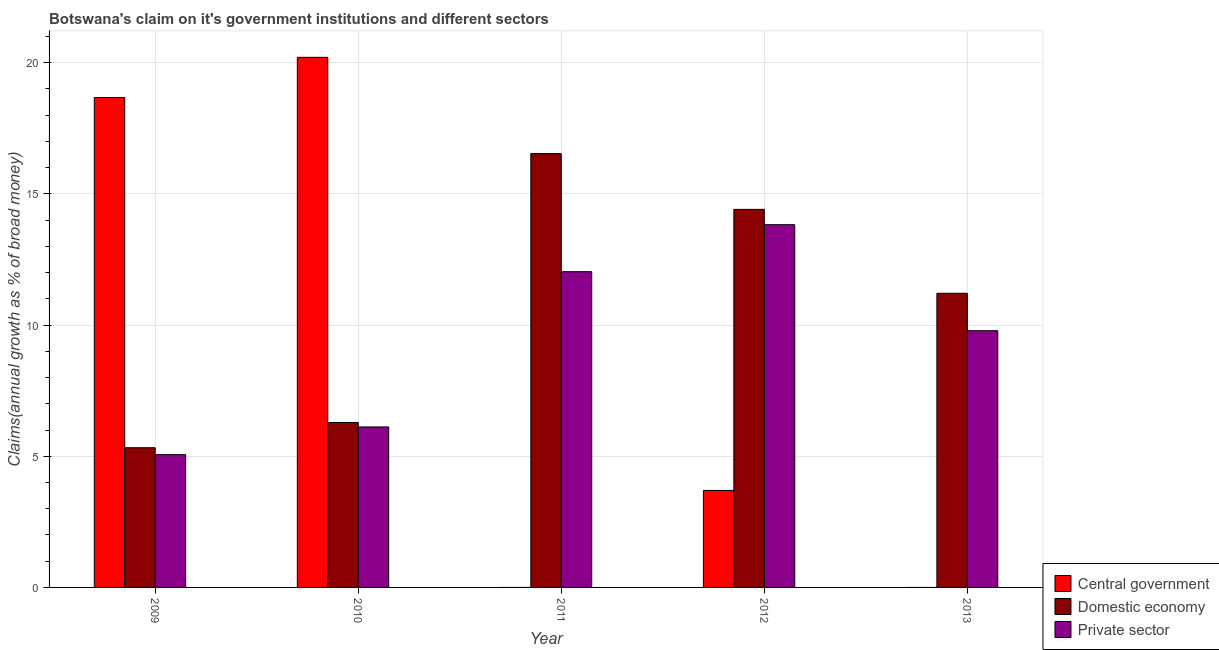How many different coloured bars are there?
Your answer should be very brief. 3. How many groups of bars are there?
Offer a terse response. 5. Are the number of bars per tick equal to the number of legend labels?
Provide a short and direct response. No. How many bars are there on the 4th tick from the left?
Your response must be concise. 3. How many bars are there on the 4th tick from the right?
Provide a succinct answer. 3. What is the label of the 5th group of bars from the left?
Ensure brevity in your answer.  2013. Across all years, what is the maximum percentage of claim on the private sector?
Give a very brief answer. 13.83. What is the total percentage of claim on the central government in the graph?
Your response must be concise. 42.58. What is the difference between the percentage of claim on the private sector in 2009 and that in 2012?
Keep it short and to the point. -8.77. What is the difference between the percentage of claim on the private sector in 2013 and the percentage of claim on the domestic economy in 2012?
Your response must be concise. -4.04. What is the average percentage of claim on the private sector per year?
Your answer should be very brief. 9.37. What is the ratio of the percentage of claim on the domestic economy in 2011 to that in 2012?
Your answer should be very brief. 1.15. Is the percentage of claim on the domestic economy in 2011 less than that in 2013?
Offer a very short reply. No. What is the difference between the highest and the second highest percentage of claim on the domestic economy?
Ensure brevity in your answer.  2.12. What is the difference between the highest and the lowest percentage of claim on the central government?
Make the answer very short. 20.21. Is the sum of the percentage of claim on the domestic economy in 2009 and 2010 greater than the maximum percentage of claim on the private sector across all years?
Make the answer very short. No. Is it the case that in every year, the sum of the percentage of claim on the central government and percentage of claim on the domestic economy is greater than the percentage of claim on the private sector?
Offer a very short reply. Yes. How many years are there in the graph?
Make the answer very short. 5. Does the graph contain any zero values?
Your answer should be very brief. Yes. Does the graph contain grids?
Offer a very short reply. Yes. How many legend labels are there?
Your answer should be very brief. 3. How are the legend labels stacked?
Ensure brevity in your answer.  Vertical. What is the title of the graph?
Provide a short and direct response. Botswana's claim on it's government institutions and different sectors. What is the label or title of the X-axis?
Provide a short and direct response. Year. What is the label or title of the Y-axis?
Offer a terse response. Claims(annual growth as % of broad money). What is the Claims(annual growth as % of broad money) in Central government in 2009?
Your response must be concise. 18.68. What is the Claims(annual growth as % of broad money) of Domestic economy in 2009?
Make the answer very short. 5.33. What is the Claims(annual growth as % of broad money) in Private sector in 2009?
Make the answer very short. 5.06. What is the Claims(annual growth as % of broad money) of Central government in 2010?
Your answer should be very brief. 20.21. What is the Claims(annual growth as % of broad money) in Domestic economy in 2010?
Your response must be concise. 6.29. What is the Claims(annual growth as % of broad money) of Private sector in 2010?
Your answer should be very brief. 6.12. What is the Claims(annual growth as % of broad money) of Central government in 2011?
Your answer should be compact. 0. What is the Claims(annual growth as % of broad money) in Domestic economy in 2011?
Keep it short and to the point. 16.54. What is the Claims(annual growth as % of broad money) in Private sector in 2011?
Your answer should be very brief. 12.04. What is the Claims(annual growth as % of broad money) of Central government in 2012?
Your answer should be compact. 3.7. What is the Claims(annual growth as % of broad money) of Domestic economy in 2012?
Offer a very short reply. 14.41. What is the Claims(annual growth as % of broad money) of Private sector in 2012?
Provide a short and direct response. 13.83. What is the Claims(annual growth as % of broad money) in Central government in 2013?
Give a very brief answer. 0. What is the Claims(annual growth as % of broad money) in Domestic economy in 2013?
Your answer should be very brief. 11.21. What is the Claims(annual growth as % of broad money) in Private sector in 2013?
Offer a very short reply. 9.79. Across all years, what is the maximum Claims(annual growth as % of broad money) of Central government?
Make the answer very short. 20.21. Across all years, what is the maximum Claims(annual growth as % of broad money) in Domestic economy?
Keep it short and to the point. 16.54. Across all years, what is the maximum Claims(annual growth as % of broad money) of Private sector?
Offer a terse response. 13.83. Across all years, what is the minimum Claims(annual growth as % of broad money) in Central government?
Your response must be concise. 0. Across all years, what is the minimum Claims(annual growth as % of broad money) of Domestic economy?
Provide a short and direct response. 5.33. Across all years, what is the minimum Claims(annual growth as % of broad money) in Private sector?
Provide a succinct answer. 5.06. What is the total Claims(annual growth as % of broad money) in Central government in the graph?
Provide a short and direct response. 42.58. What is the total Claims(annual growth as % of broad money) of Domestic economy in the graph?
Offer a terse response. 53.77. What is the total Claims(annual growth as % of broad money) of Private sector in the graph?
Your response must be concise. 46.83. What is the difference between the Claims(annual growth as % of broad money) of Central government in 2009 and that in 2010?
Keep it short and to the point. -1.53. What is the difference between the Claims(annual growth as % of broad money) of Domestic economy in 2009 and that in 2010?
Ensure brevity in your answer.  -0.96. What is the difference between the Claims(annual growth as % of broad money) of Private sector in 2009 and that in 2010?
Your answer should be very brief. -1.06. What is the difference between the Claims(annual growth as % of broad money) of Domestic economy in 2009 and that in 2011?
Ensure brevity in your answer.  -11.21. What is the difference between the Claims(annual growth as % of broad money) in Private sector in 2009 and that in 2011?
Keep it short and to the point. -6.97. What is the difference between the Claims(annual growth as % of broad money) in Central government in 2009 and that in 2012?
Give a very brief answer. 14.98. What is the difference between the Claims(annual growth as % of broad money) of Domestic economy in 2009 and that in 2012?
Your answer should be compact. -9.09. What is the difference between the Claims(annual growth as % of broad money) of Private sector in 2009 and that in 2012?
Provide a short and direct response. -8.77. What is the difference between the Claims(annual growth as % of broad money) of Domestic economy in 2009 and that in 2013?
Your answer should be very brief. -5.89. What is the difference between the Claims(annual growth as % of broad money) in Private sector in 2009 and that in 2013?
Provide a short and direct response. -4.73. What is the difference between the Claims(annual growth as % of broad money) in Domestic economy in 2010 and that in 2011?
Offer a very short reply. -10.25. What is the difference between the Claims(annual growth as % of broad money) in Private sector in 2010 and that in 2011?
Your response must be concise. -5.92. What is the difference between the Claims(annual growth as % of broad money) of Central government in 2010 and that in 2012?
Your answer should be very brief. 16.51. What is the difference between the Claims(annual growth as % of broad money) in Domestic economy in 2010 and that in 2012?
Provide a succinct answer. -8.12. What is the difference between the Claims(annual growth as % of broad money) of Private sector in 2010 and that in 2012?
Provide a short and direct response. -7.71. What is the difference between the Claims(annual growth as % of broad money) of Domestic economy in 2010 and that in 2013?
Offer a terse response. -4.92. What is the difference between the Claims(annual growth as % of broad money) of Private sector in 2010 and that in 2013?
Keep it short and to the point. -3.67. What is the difference between the Claims(annual growth as % of broad money) of Domestic economy in 2011 and that in 2012?
Give a very brief answer. 2.12. What is the difference between the Claims(annual growth as % of broad money) in Private sector in 2011 and that in 2012?
Your response must be concise. -1.79. What is the difference between the Claims(annual growth as % of broad money) in Domestic economy in 2011 and that in 2013?
Provide a succinct answer. 5.32. What is the difference between the Claims(annual growth as % of broad money) in Private sector in 2011 and that in 2013?
Give a very brief answer. 2.25. What is the difference between the Claims(annual growth as % of broad money) of Domestic economy in 2012 and that in 2013?
Provide a succinct answer. 3.2. What is the difference between the Claims(annual growth as % of broad money) in Private sector in 2012 and that in 2013?
Offer a very short reply. 4.04. What is the difference between the Claims(annual growth as % of broad money) in Central government in 2009 and the Claims(annual growth as % of broad money) in Domestic economy in 2010?
Provide a short and direct response. 12.39. What is the difference between the Claims(annual growth as % of broad money) of Central government in 2009 and the Claims(annual growth as % of broad money) of Private sector in 2010?
Keep it short and to the point. 12.56. What is the difference between the Claims(annual growth as % of broad money) in Domestic economy in 2009 and the Claims(annual growth as % of broad money) in Private sector in 2010?
Your answer should be compact. -0.79. What is the difference between the Claims(annual growth as % of broad money) in Central government in 2009 and the Claims(annual growth as % of broad money) in Domestic economy in 2011?
Your answer should be compact. 2.14. What is the difference between the Claims(annual growth as % of broad money) in Central government in 2009 and the Claims(annual growth as % of broad money) in Private sector in 2011?
Your answer should be compact. 6.64. What is the difference between the Claims(annual growth as % of broad money) in Domestic economy in 2009 and the Claims(annual growth as % of broad money) in Private sector in 2011?
Make the answer very short. -6.71. What is the difference between the Claims(annual growth as % of broad money) of Central government in 2009 and the Claims(annual growth as % of broad money) of Domestic economy in 2012?
Your response must be concise. 4.26. What is the difference between the Claims(annual growth as % of broad money) of Central government in 2009 and the Claims(annual growth as % of broad money) of Private sector in 2012?
Your response must be concise. 4.85. What is the difference between the Claims(annual growth as % of broad money) of Domestic economy in 2009 and the Claims(annual growth as % of broad money) of Private sector in 2012?
Your answer should be very brief. -8.5. What is the difference between the Claims(annual growth as % of broad money) in Central government in 2009 and the Claims(annual growth as % of broad money) in Domestic economy in 2013?
Ensure brevity in your answer.  7.46. What is the difference between the Claims(annual growth as % of broad money) in Central government in 2009 and the Claims(annual growth as % of broad money) in Private sector in 2013?
Ensure brevity in your answer.  8.89. What is the difference between the Claims(annual growth as % of broad money) of Domestic economy in 2009 and the Claims(annual growth as % of broad money) of Private sector in 2013?
Your answer should be very brief. -4.46. What is the difference between the Claims(annual growth as % of broad money) in Central government in 2010 and the Claims(annual growth as % of broad money) in Domestic economy in 2011?
Make the answer very short. 3.67. What is the difference between the Claims(annual growth as % of broad money) of Central government in 2010 and the Claims(annual growth as % of broad money) of Private sector in 2011?
Offer a very short reply. 8.17. What is the difference between the Claims(annual growth as % of broad money) of Domestic economy in 2010 and the Claims(annual growth as % of broad money) of Private sector in 2011?
Keep it short and to the point. -5.75. What is the difference between the Claims(annual growth as % of broad money) of Central government in 2010 and the Claims(annual growth as % of broad money) of Domestic economy in 2012?
Keep it short and to the point. 5.8. What is the difference between the Claims(annual growth as % of broad money) of Central government in 2010 and the Claims(annual growth as % of broad money) of Private sector in 2012?
Your answer should be very brief. 6.38. What is the difference between the Claims(annual growth as % of broad money) in Domestic economy in 2010 and the Claims(annual growth as % of broad money) in Private sector in 2012?
Offer a terse response. -7.54. What is the difference between the Claims(annual growth as % of broad money) in Central government in 2010 and the Claims(annual growth as % of broad money) in Domestic economy in 2013?
Your answer should be compact. 8.99. What is the difference between the Claims(annual growth as % of broad money) of Central government in 2010 and the Claims(annual growth as % of broad money) of Private sector in 2013?
Give a very brief answer. 10.42. What is the difference between the Claims(annual growth as % of broad money) in Domestic economy in 2010 and the Claims(annual growth as % of broad money) in Private sector in 2013?
Give a very brief answer. -3.5. What is the difference between the Claims(annual growth as % of broad money) of Domestic economy in 2011 and the Claims(annual growth as % of broad money) of Private sector in 2012?
Provide a short and direct response. 2.71. What is the difference between the Claims(annual growth as % of broad money) of Domestic economy in 2011 and the Claims(annual growth as % of broad money) of Private sector in 2013?
Your answer should be compact. 6.75. What is the difference between the Claims(annual growth as % of broad money) in Central government in 2012 and the Claims(annual growth as % of broad money) in Domestic economy in 2013?
Provide a succinct answer. -7.52. What is the difference between the Claims(annual growth as % of broad money) in Central government in 2012 and the Claims(annual growth as % of broad money) in Private sector in 2013?
Provide a short and direct response. -6.09. What is the difference between the Claims(annual growth as % of broad money) of Domestic economy in 2012 and the Claims(annual growth as % of broad money) of Private sector in 2013?
Keep it short and to the point. 4.62. What is the average Claims(annual growth as % of broad money) of Central government per year?
Provide a succinct answer. 8.52. What is the average Claims(annual growth as % of broad money) of Domestic economy per year?
Ensure brevity in your answer.  10.75. What is the average Claims(annual growth as % of broad money) in Private sector per year?
Give a very brief answer. 9.37. In the year 2009, what is the difference between the Claims(annual growth as % of broad money) in Central government and Claims(annual growth as % of broad money) in Domestic economy?
Ensure brevity in your answer.  13.35. In the year 2009, what is the difference between the Claims(annual growth as % of broad money) in Central government and Claims(annual growth as % of broad money) in Private sector?
Your answer should be compact. 13.61. In the year 2009, what is the difference between the Claims(annual growth as % of broad money) of Domestic economy and Claims(annual growth as % of broad money) of Private sector?
Your answer should be compact. 0.26. In the year 2010, what is the difference between the Claims(annual growth as % of broad money) in Central government and Claims(annual growth as % of broad money) in Domestic economy?
Offer a very short reply. 13.92. In the year 2010, what is the difference between the Claims(annual growth as % of broad money) of Central government and Claims(annual growth as % of broad money) of Private sector?
Ensure brevity in your answer.  14.09. In the year 2010, what is the difference between the Claims(annual growth as % of broad money) of Domestic economy and Claims(annual growth as % of broad money) of Private sector?
Give a very brief answer. 0.17. In the year 2011, what is the difference between the Claims(annual growth as % of broad money) in Domestic economy and Claims(annual growth as % of broad money) in Private sector?
Ensure brevity in your answer.  4.5. In the year 2012, what is the difference between the Claims(annual growth as % of broad money) of Central government and Claims(annual growth as % of broad money) of Domestic economy?
Your response must be concise. -10.71. In the year 2012, what is the difference between the Claims(annual growth as % of broad money) in Central government and Claims(annual growth as % of broad money) in Private sector?
Give a very brief answer. -10.13. In the year 2012, what is the difference between the Claims(annual growth as % of broad money) in Domestic economy and Claims(annual growth as % of broad money) in Private sector?
Give a very brief answer. 0.58. In the year 2013, what is the difference between the Claims(annual growth as % of broad money) in Domestic economy and Claims(annual growth as % of broad money) in Private sector?
Offer a very short reply. 1.43. What is the ratio of the Claims(annual growth as % of broad money) in Central government in 2009 to that in 2010?
Make the answer very short. 0.92. What is the ratio of the Claims(annual growth as % of broad money) in Domestic economy in 2009 to that in 2010?
Give a very brief answer. 0.85. What is the ratio of the Claims(annual growth as % of broad money) of Private sector in 2009 to that in 2010?
Offer a very short reply. 0.83. What is the ratio of the Claims(annual growth as % of broad money) in Domestic economy in 2009 to that in 2011?
Your response must be concise. 0.32. What is the ratio of the Claims(annual growth as % of broad money) in Private sector in 2009 to that in 2011?
Offer a terse response. 0.42. What is the ratio of the Claims(annual growth as % of broad money) of Central government in 2009 to that in 2012?
Your answer should be very brief. 5.05. What is the ratio of the Claims(annual growth as % of broad money) of Domestic economy in 2009 to that in 2012?
Your answer should be compact. 0.37. What is the ratio of the Claims(annual growth as % of broad money) of Private sector in 2009 to that in 2012?
Provide a succinct answer. 0.37. What is the ratio of the Claims(annual growth as % of broad money) in Domestic economy in 2009 to that in 2013?
Give a very brief answer. 0.47. What is the ratio of the Claims(annual growth as % of broad money) in Private sector in 2009 to that in 2013?
Offer a very short reply. 0.52. What is the ratio of the Claims(annual growth as % of broad money) in Domestic economy in 2010 to that in 2011?
Your response must be concise. 0.38. What is the ratio of the Claims(annual growth as % of broad money) of Private sector in 2010 to that in 2011?
Keep it short and to the point. 0.51. What is the ratio of the Claims(annual growth as % of broad money) of Central government in 2010 to that in 2012?
Offer a terse response. 5.46. What is the ratio of the Claims(annual growth as % of broad money) in Domestic economy in 2010 to that in 2012?
Offer a very short reply. 0.44. What is the ratio of the Claims(annual growth as % of broad money) in Private sector in 2010 to that in 2012?
Offer a very short reply. 0.44. What is the ratio of the Claims(annual growth as % of broad money) in Domestic economy in 2010 to that in 2013?
Ensure brevity in your answer.  0.56. What is the ratio of the Claims(annual growth as % of broad money) in Private sector in 2010 to that in 2013?
Provide a short and direct response. 0.63. What is the ratio of the Claims(annual growth as % of broad money) of Domestic economy in 2011 to that in 2012?
Your response must be concise. 1.15. What is the ratio of the Claims(annual growth as % of broad money) in Private sector in 2011 to that in 2012?
Offer a terse response. 0.87. What is the ratio of the Claims(annual growth as % of broad money) in Domestic economy in 2011 to that in 2013?
Provide a succinct answer. 1.47. What is the ratio of the Claims(annual growth as % of broad money) in Private sector in 2011 to that in 2013?
Your answer should be compact. 1.23. What is the ratio of the Claims(annual growth as % of broad money) in Domestic economy in 2012 to that in 2013?
Your response must be concise. 1.29. What is the ratio of the Claims(annual growth as % of broad money) of Private sector in 2012 to that in 2013?
Your answer should be very brief. 1.41. What is the difference between the highest and the second highest Claims(annual growth as % of broad money) of Central government?
Your answer should be compact. 1.53. What is the difference between the highest and the second highest Claims(annual growth as % of broad money) of Domestic economy?
Provide a succinct answer. 2.12. What is the difference between the highest and the second highest Claims(annual growth as % of broad money) of Private sector?
Provide a succinct answer. 1.79. What is the difference between the highest and the lowest Claims(annual growth as % of broad money) of Central government?
Your response must be concise. 20.21. What is the difference between the highest and the lowest Claims(annual growth as % of broad money) in Domestic economy?
Offer a very short reply. 11.21. What is the difference between the highest and the lowest Claims(annual growth as % of broad money) in Private sector?
Provide a succinct answer. 8.77. 